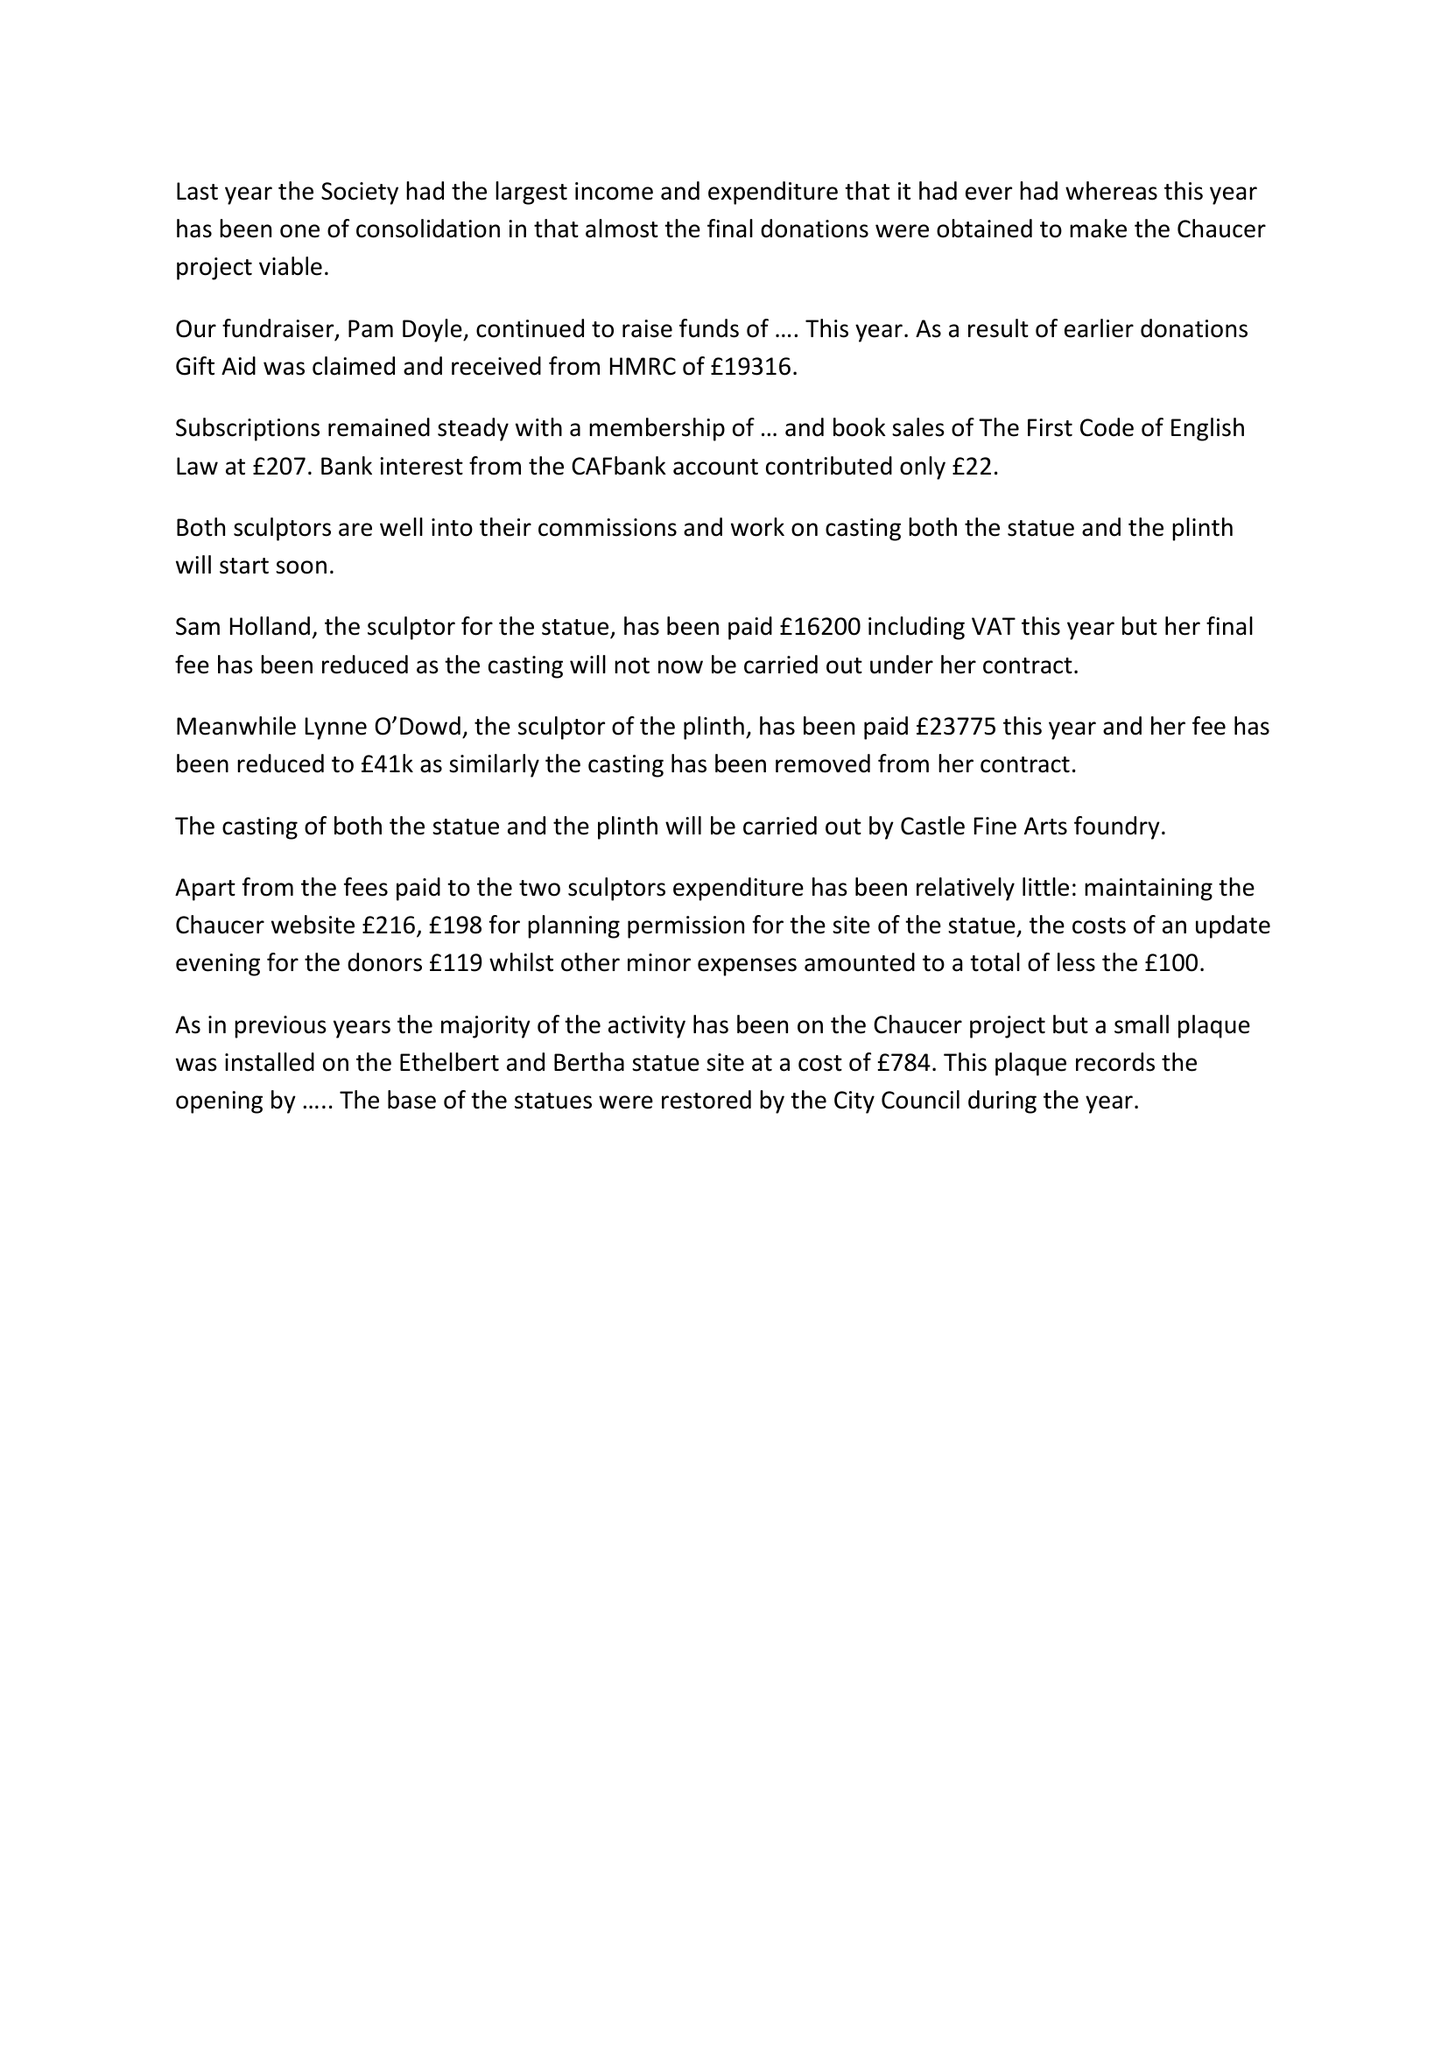What is the value for the income_annually_in_british_pounds?
Answer the question using a single word or phrase. 62935.00 